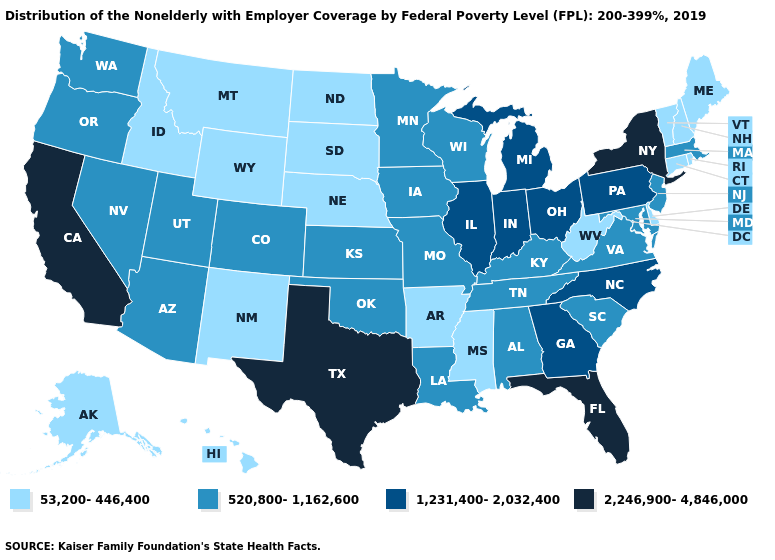Does Louisiana have the lowest value in the USA?
Concise answer only. No. Does Pennsylvania have the lowest value in the USA?
Keep it brief. No. Does California have the highest value in the West?
Quick response, please. Yes. Name the states that have a value in the range 1,231,400-2,032,400?
Concise answer only. Georgia, Illinois, Indiana, Michigan, North Carolina, Ohio, Pennsylvania. Among the states that border Indiana , does Kentucky have the highest value?
Answer briefly. No. Which states have the lowest value in the Northeast?
Be succinct. Connecticut, Maine, New Hampshire, Rhode Island, Vermont. Does California have a higher value than Oregon?
Give a very brief answer. Yes. Does the first symbol in the legend represent the smallest category?
Concise answer only. Yes. What is the lowest value in the USA?
Short answer required. 53,200-446,400. Name the states that have a value in the range 1,231,400-2,032,400?
Give a very brief answer. Georgia, Illinois, Indiana, Michigan, North Carolina, Ohio, Pennsylvania. What is the value of Vermont?
Quick response, please. 53,200-446,400. What is the lowest value in the West?
Be succinct. 53,200-446,400. What is the value of Nebraska?
Answer briefly. 53,200-446,400. 